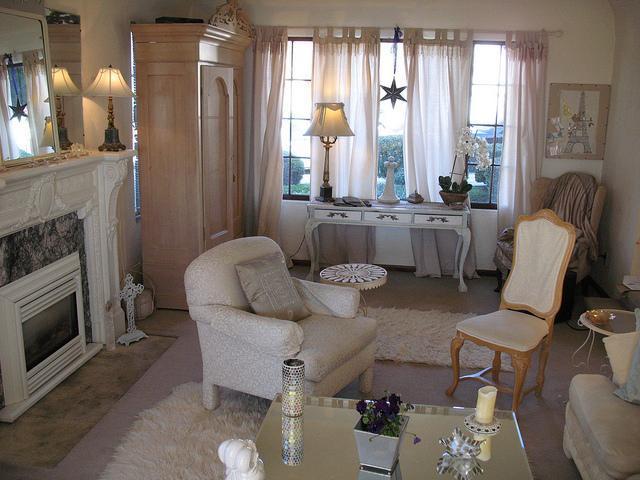How many stars are in the room?
Give a very brief answer. 1. How many chairs are in the picture?
Give a very brief answer. 3. How many people have their hands showing?
Give a very brief answer. 0. 